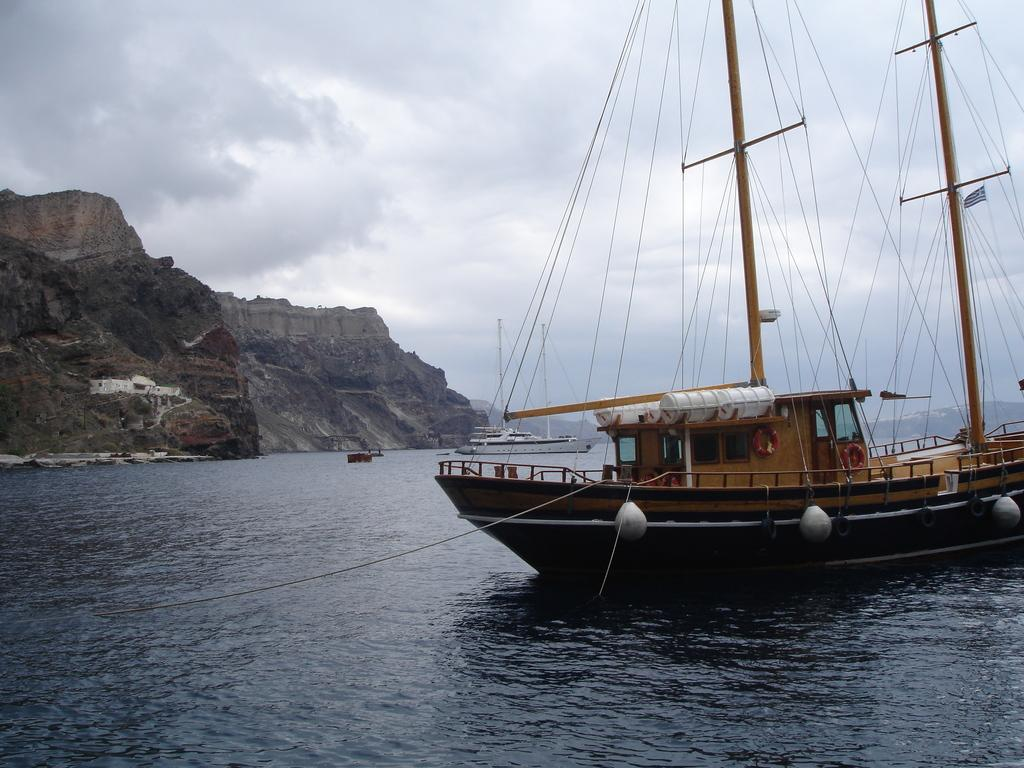What is the main element present in the image? The image contains water. What can be seen on the right side of the image? There is a ship on the right side of the image. What type of landform is visible on the left side of the image? There are hills on the left side of the image. What is visible at the top of the image? The sky is visible at the top of the image. What is the condition of the scale in the image? There is no scale present in the image. How does the roll of fabric move in the image? There is no roll of fabric present in the image. 